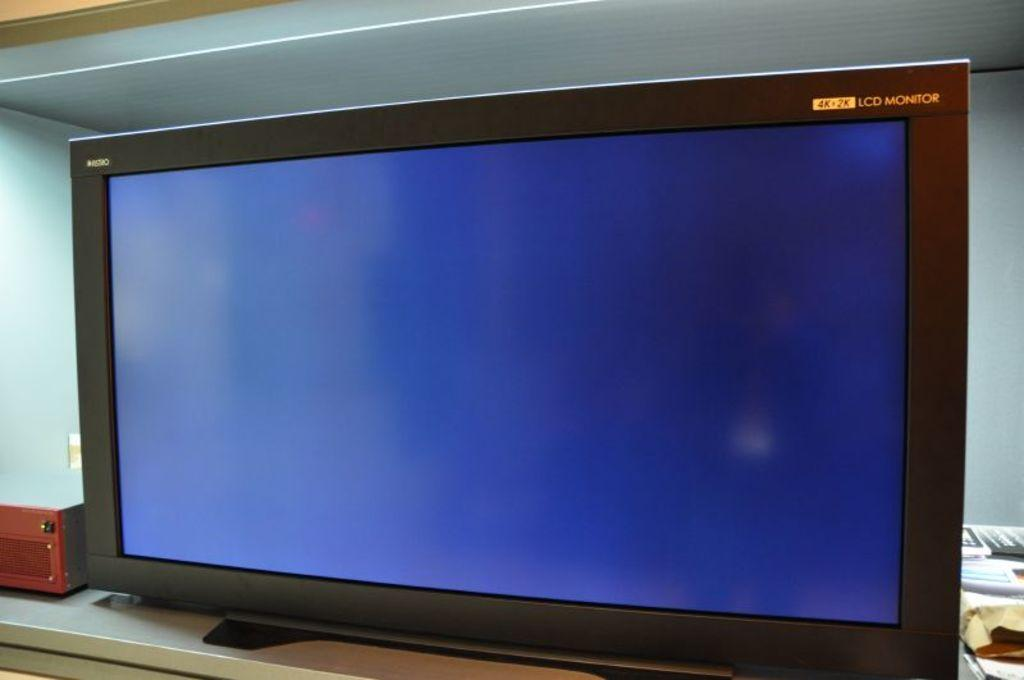<image>
Present a compact description of the photo's key features. Monitor screen that says the words LCD monitor on the top right. 